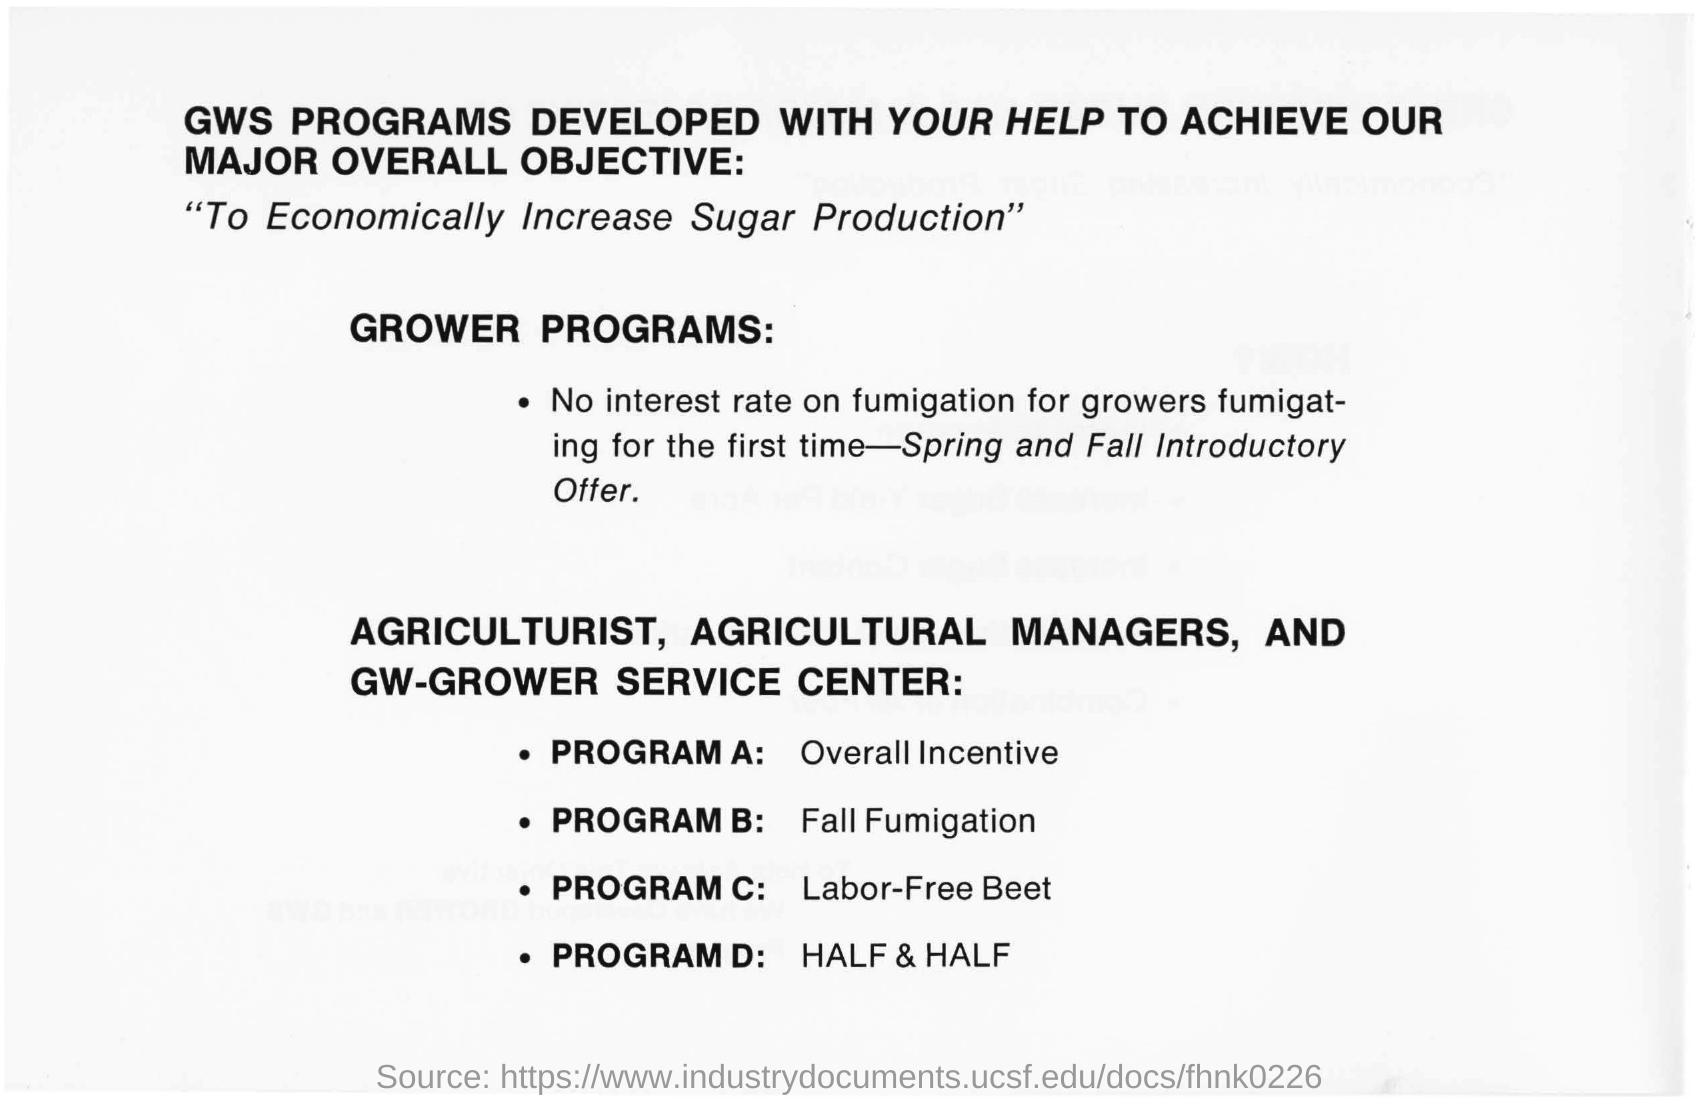What is written in the top of the document ?
Keep it short and to the point. GWS PROGRAMS DEVELOPED WITH YOUR HELP TO ACHIEVE OUR MAJOR OVERALL OBJECTIVE:. What is the Program A ?
Give a very brief answer. Overall Incentive. What is the Program C ?
Your answer should be compact. Labor-Free Beet. What is the Program B ?
Offer a terse response. Fall Fumigation. What is the Program D ?
Your response must be concise. HALF & HALF. 